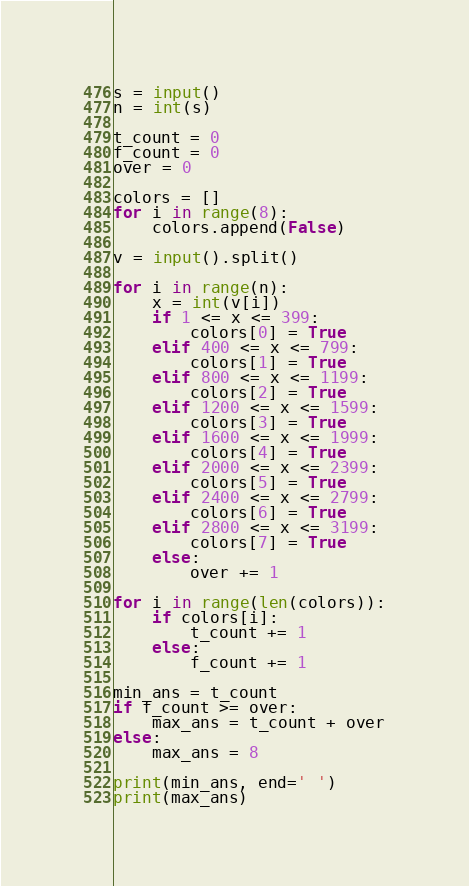<code> <loc_0><loc_0><loc_500><loc_500><_Python_>s = input()
n = int(s)

t_count = 0
f_count = 0
over = 0

colors = []
for i in range(8):
    colors.append(False)

v = input().split()

for i in range(n):
    x = int(v[i])
    if 1 <= x <= 399:
        colors[0] = True
    elif 400 <= x <= 799:
        colors[1] = True
    elif 800 <= x <= 1199:
        colors[2] = True
    elif 1200 <= x <= 1599:
        colors[3] = True
    elif 1600 <= x <= 1999:
        colors[4] = True
    elif 2000 <= x <= 2399:
        colors[5] = True
    elif 2400 <= x <= 2799:
        colors[6] = True
    elif 2800 <= x <= 3199:
        colors[7] = True
    else:
        over += 1

for i in range(len(colors)):
    if colors[i]:
        t_count += 1
    else:
        f_count += 1

min_ans = t_count
if f_count >= over:
    max_ans = t_count + over
else:
    max_ans = 8

print(min_ans, end=' ')
print(max_ans)

</code> 